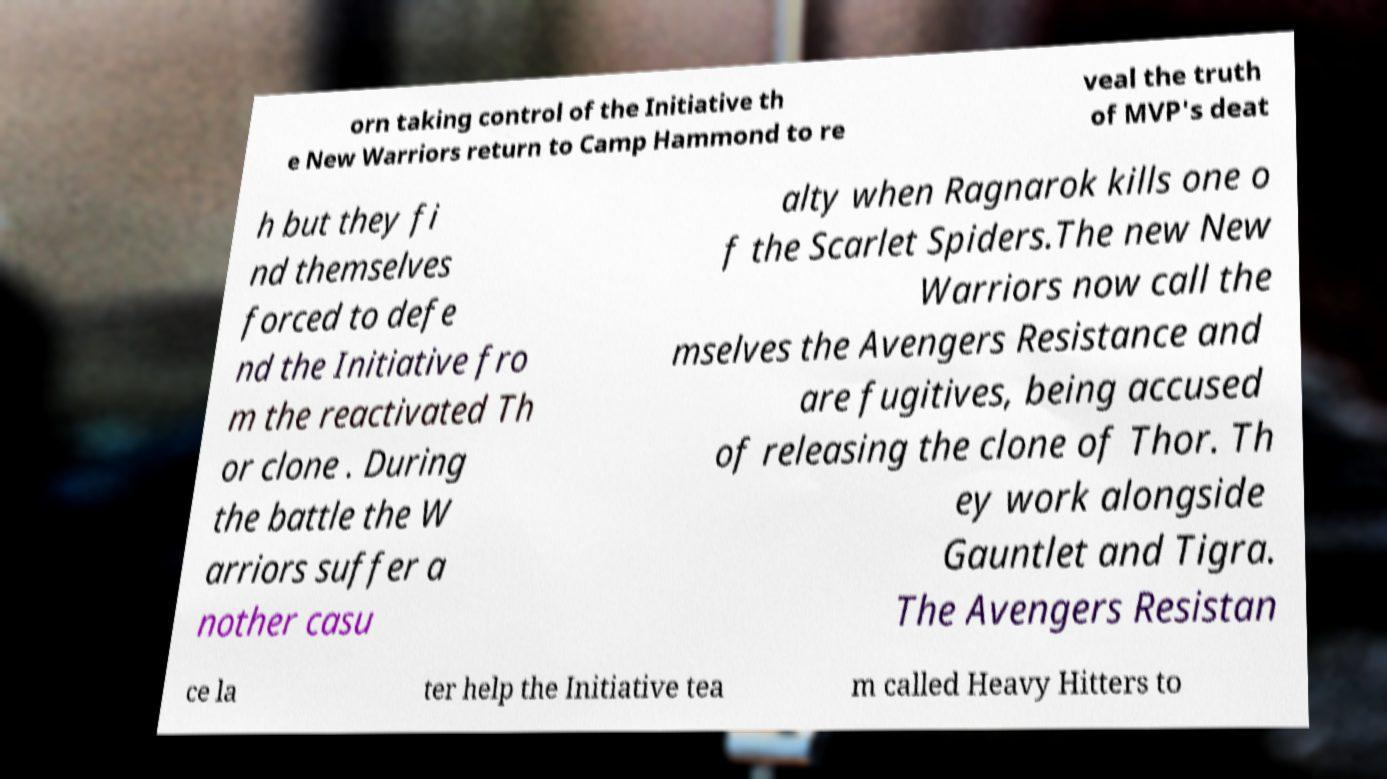Please read and relay the text visible in this image. What does it say? orn taking control of the Initiative th e New Warriors return to Camp Hammond to re veal the truth of MVP's deat h but they fi nd themselves forced to defe nd the Initiative fro m the reactivated Th or clone . During the battle the W arriors suffer a nother casu alty when Ragnarok kills one o f the Scarlet Spiders.The new New Warriors now call the mselves the Avengers Resistance and are fugitives, being accused of releasing the clone of Thor. Th ey work alongside Gauntlet and Tigra. The Avengers Resistan ce la ter help the Initiative tea m called Heavy Hitters to 